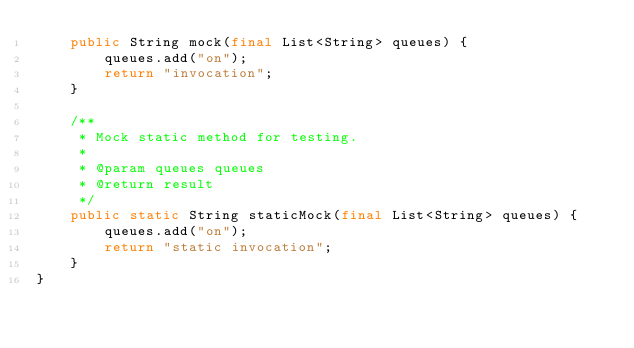Convert code to text. <code><loc_0><loc_0><loc_500><loc_500><_Java_>    public String mock(final List<String> queues) {
        queues.add("on");
        return "invocation";
    }
    
    /**
     * Mock static method for testing.
     *
     * @param queues queues
     * @return result
     */
    public static String staticMock(final List<String> queues) {
        queues.add("on");
        return "static invocation";
    }
}
</code> 